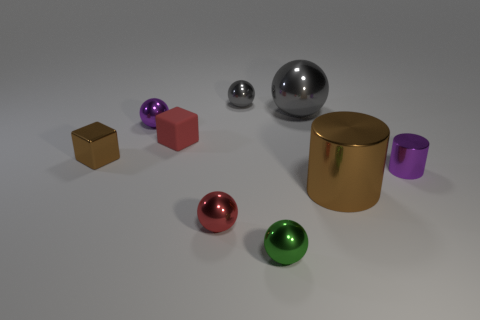Subtract all red spheres. How many spheres are left? 4 Subtract all brown spheres. Subtract all gray cubes. How many spheres are left? 5 Add 1 tiny red rubber objects. How many objects exist? 10 Subtract all balls. How many objects are left? 4 Add 2 brown cubes. How many brown cubes are left? 3 Add 3 large metallic objects. How many large metallic objects exist? 5 Subtract 0 blue spheres. How many objects are left? 9 Subtract all green metallic spheres. Subtract all tiny red balls. How many objects are left? 7 